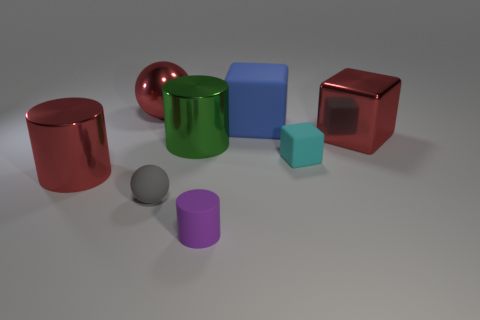Do the large shiny ball and the metallic block have the same color?
Your response must be concise. Yes. How many large red objects are on the right side of the red cylinder and on the left side of the tiny block?
Provide a succinct answer. 1. There is a red object in front of the tiny cyan block; what is its shape?
Provide a short and direct response. Cylinder. Are there fewer large red spheres in front of the big rubber thing than big metal spheres to the right of the tiny purple thing?
Keep it short and to the point. No. Do the cylinder that is in front of the red metallic cylinder and the red thing that is to the right of the small purple cylinder have the same material?
Offer a very short reply. No. What shape is the small gray thing?
Give a very brief answer. Sphere. Is the number of red shiny cylinders right of the big matte thing greater than the number of red balls on the right side of the small purple object?
Give a very brief answer. No. Does the large metal thing that is right of the tiny cyan object have the same shape as the green object behind the small cyan rubber block?
Ensure brevity in your answer.  No. How many other things are there of the same size as the red sphere?
Offer a very short reply. 4. The red sphere is what size?
Your answer should be very brief. Large. 